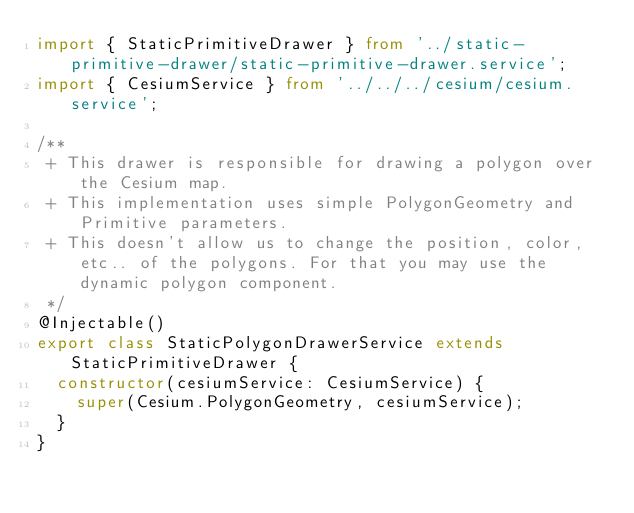<code> <loc_0><loc_0><loc_500><loc_500><_TypeScript_>import { StaticPrimitiveDrawer } from '../static-primitive-drawer/static-primitive-drawer.service';
import { CesiumService } from '../../../cesium/cesium.service';

/**
 + This drawer is responsible for drawing a polygon over the Cesium map.
 + This implementation uses simple PolygonGeometry and Primitive parameters.
 + This doesn't allow us to change the position, color, etc.. of the polygons. For that you may use the dynamic polygon component.
 */
@Injectable()
export class StaticPolygonDrawerService extends StaticPrimitiveDrawer {
  constructor(cesiumService: CesiumService) {
    super(Cesium.PolygonGeometry, cesiumService);
  }
}
</code> 